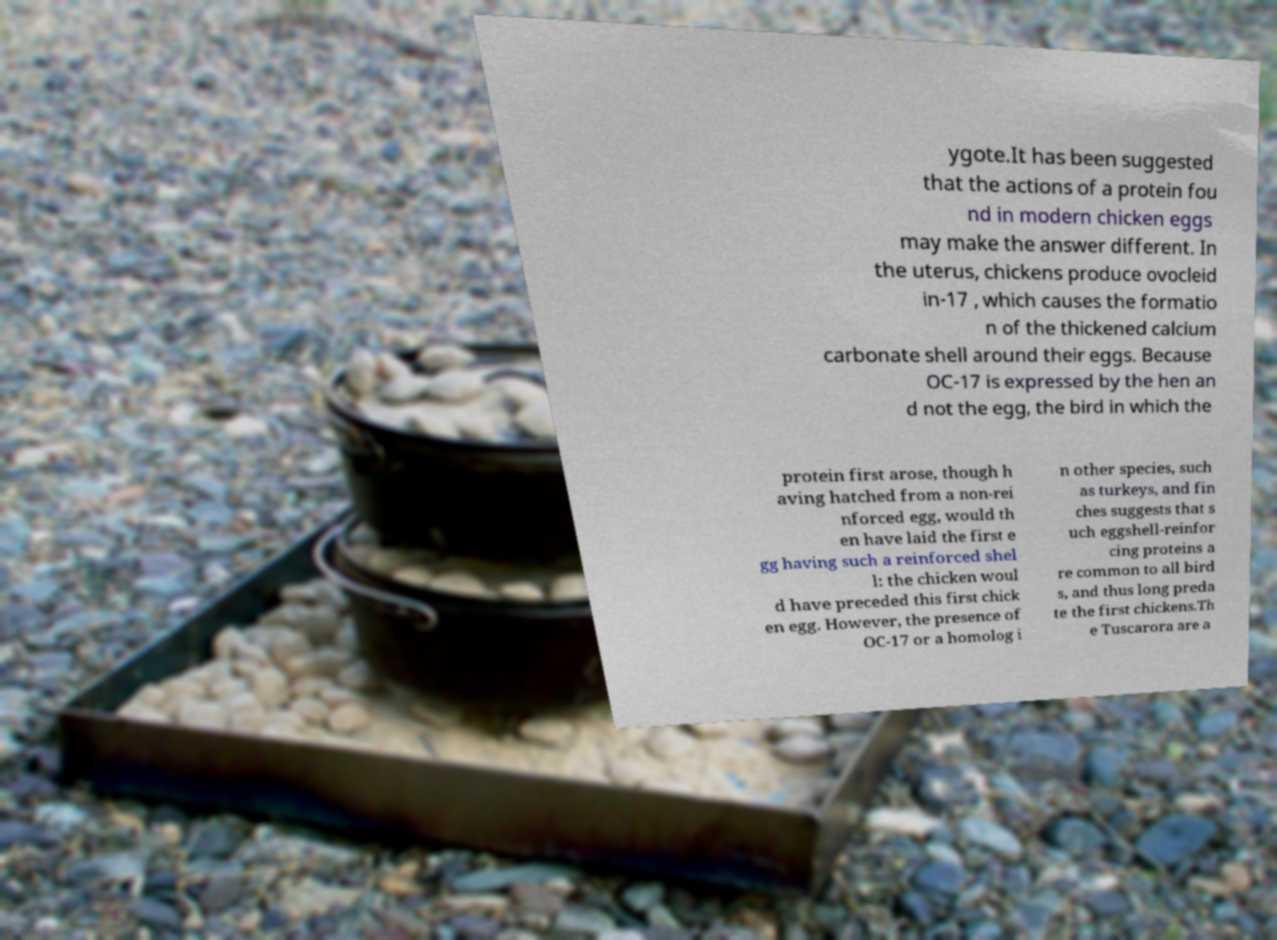What messages or text are displayed in this image? I need them in a readable, typed format. ygote.It has been suggested that the actions of a protein fou nd in modern chicken eggs may make the answer different. In the uterus, chickens produce ovocleid in-17 , which causes the formatio n of the thickened calcium carbonate shell around their eggs. Because OC-17 is expressed by the hen an d not the egg, the bird in which the protein first arose, though h aving hatched from a non-rei nforced egg, would th en have laid the first e gg having such a reinforced shel l: the chicken woul d have preceded this first chick en egg. However, the presence of OC-17 or a homolog i n other species, such as turkeys, and fin ches suggests that s uch eggshell-reinfor cing proteins a re common to all bird s, and thus long preda te the first chickens.Th e Tuscarora are a 